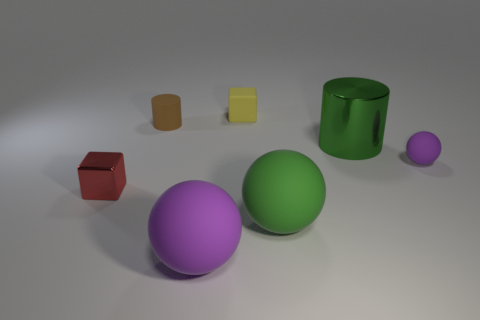Subtract all purple spheres. Subtract all gray cubes. How many spheres are left? 1 Add 3 tiny green shiny cylinders. How many objects exist? 10 Subtract all cylinders. How many objects are left? 5 Add 5 big purple rubber spheres. How many big purple rubber spheres are left? 6 Add 7 tiny purple metal things. How many tiny purple metal things exist? 7 Subtract 0 gray cylinders. How many objects are left? 7 Subtract all tiny red things. Subtract all tiny cylinders. How many objects are left? 5 